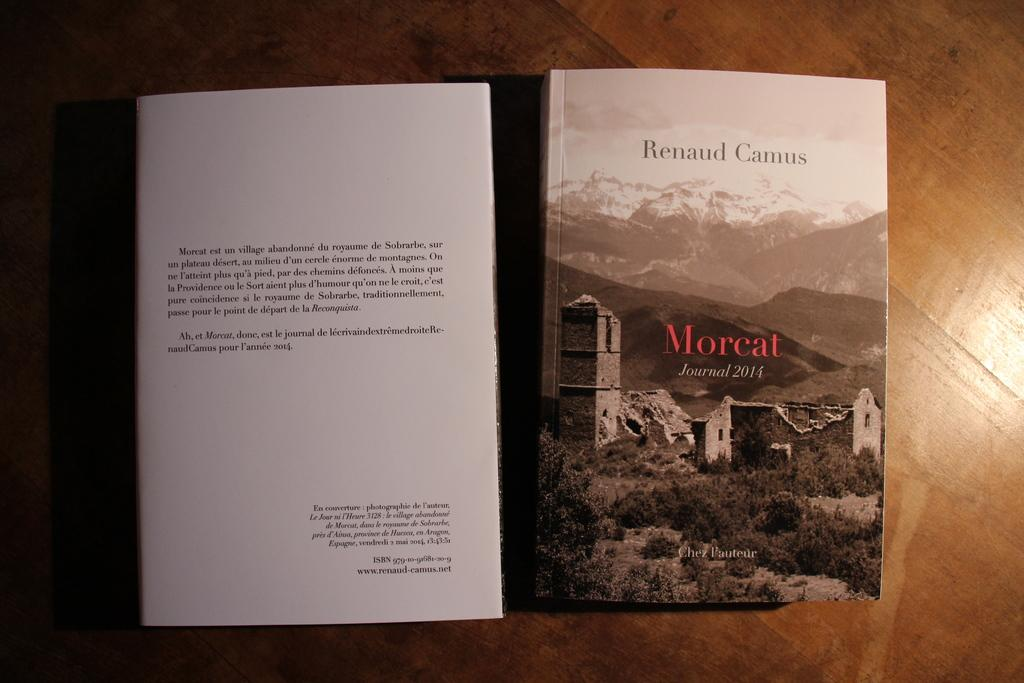Provide a one-sentence caption for the provided image. A scenic view is on the front of the Morcat journal 2014. 